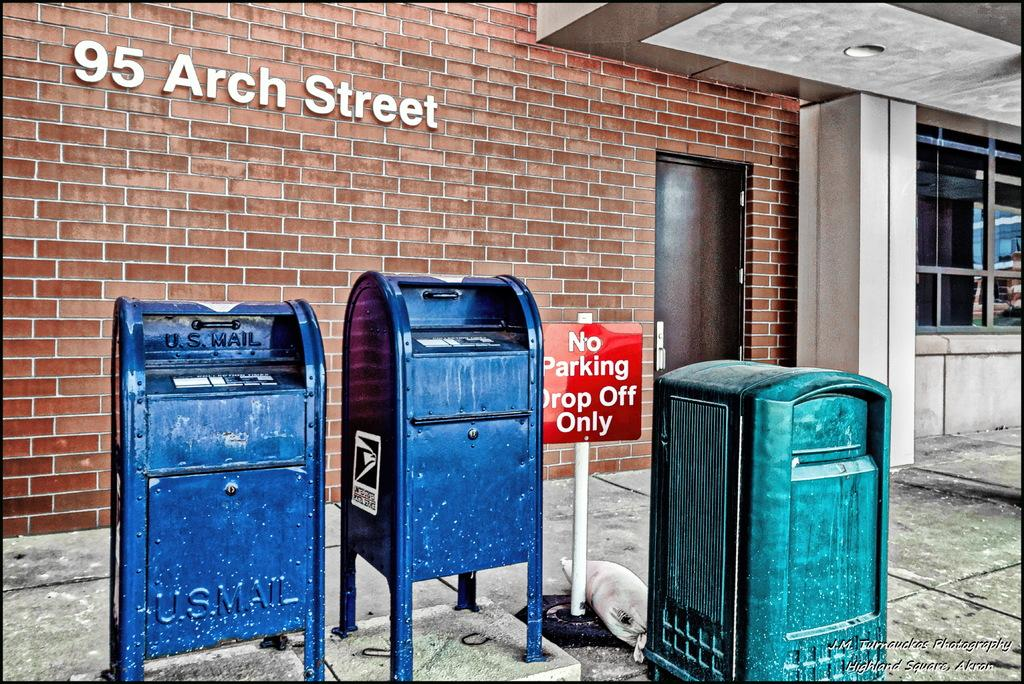<image>
Relay a brief, clear account of the picture shown. U.S Mail postal boxes outside on 95 arch street 